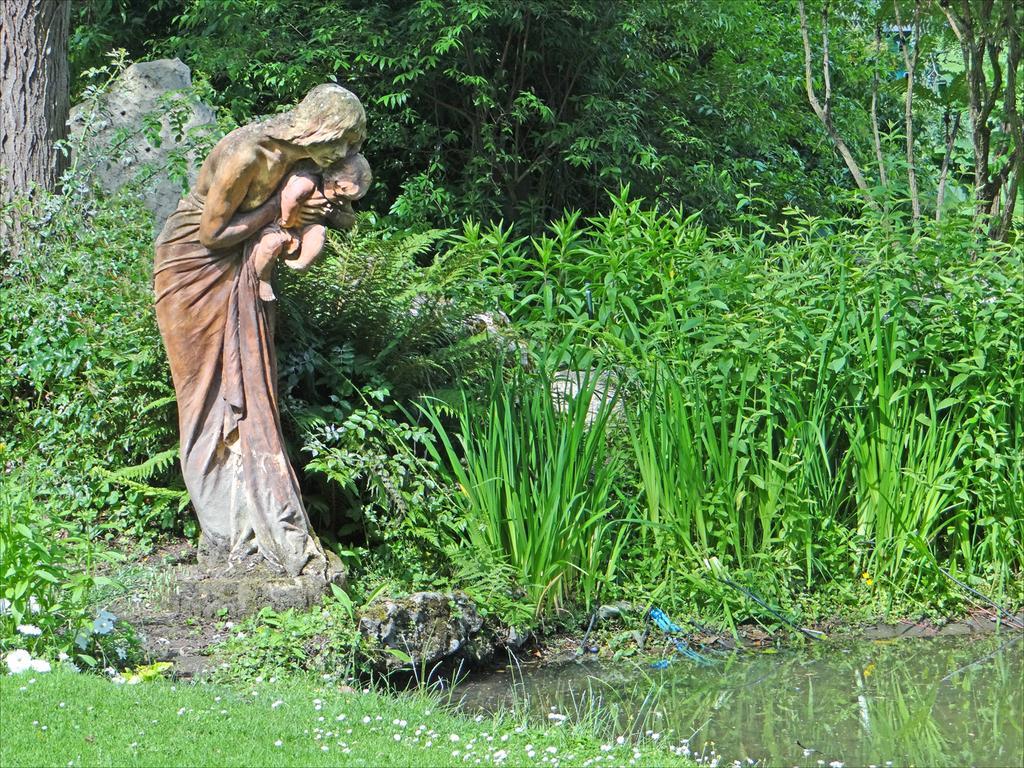Can you describe this image briefly? In this image we can see a statue. In the background of the image there are trees, plants. At the bottom of the image there is grass. To the right side of the image there is water. 